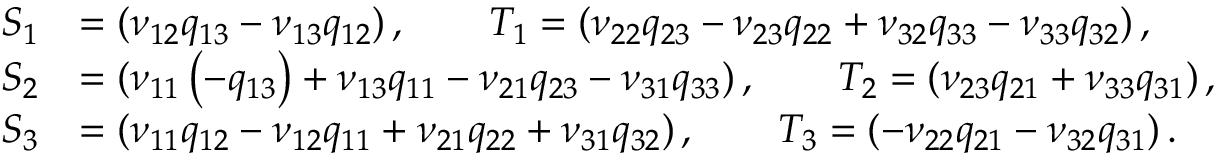Convert formula to latex. <formula><loc_0><loc_0><loc_500><loc_500>\begin{array} { r l } { S _ { 1 } } & { = ( \nu _ { 1 2 } q _ { 1 3 } - \nu _ { 1 3 } q _ { 1 2 } ) \, , \quad T _ { 1 } = ( \nu _ { 2 2 } q _ { 2 3 } - \nu _ { 2 3 } q _ { 2 2 } + \nu _ { 3 2 } q _ { 3 3 } - \nu _ { 3 3 } q _ { 3 2 } ) \, , } \\ { S _ { 2 } } & { = ( \nu _ { 1 1 } \left ( - q _ { 1 3 } \right ) + \nu _ { 1 3 } q _ { 1 1 } - \nu _ { 2 1 } q _ { 2 3 } - \nu _ { 3 1 } q _ { 3 3 } ) \, , \quad T _ { 2 } = ( \nu _ { 2 3 } q _ { 2 1 } + \nu _ { 3 3 } q _ { 3 1 } ) \, , } \\ { S _ { 3 } } & { = ( \nu _ { 1 1 } q _ { 1 2 } - \nu _ { 1 2 } q _ { 1 1 } + \nu _ { 2 1 } q _ { 2 2 } + \nu _ { 3 1 } q _ { 3 2 } ) \, , \quad T _ { 3 } = ( - \nu _ { 2 2 } q _ { 2 1 } - \nu _ { 3 2 } q _ { 3 1 } ) \, . } \end{array}</formula> 